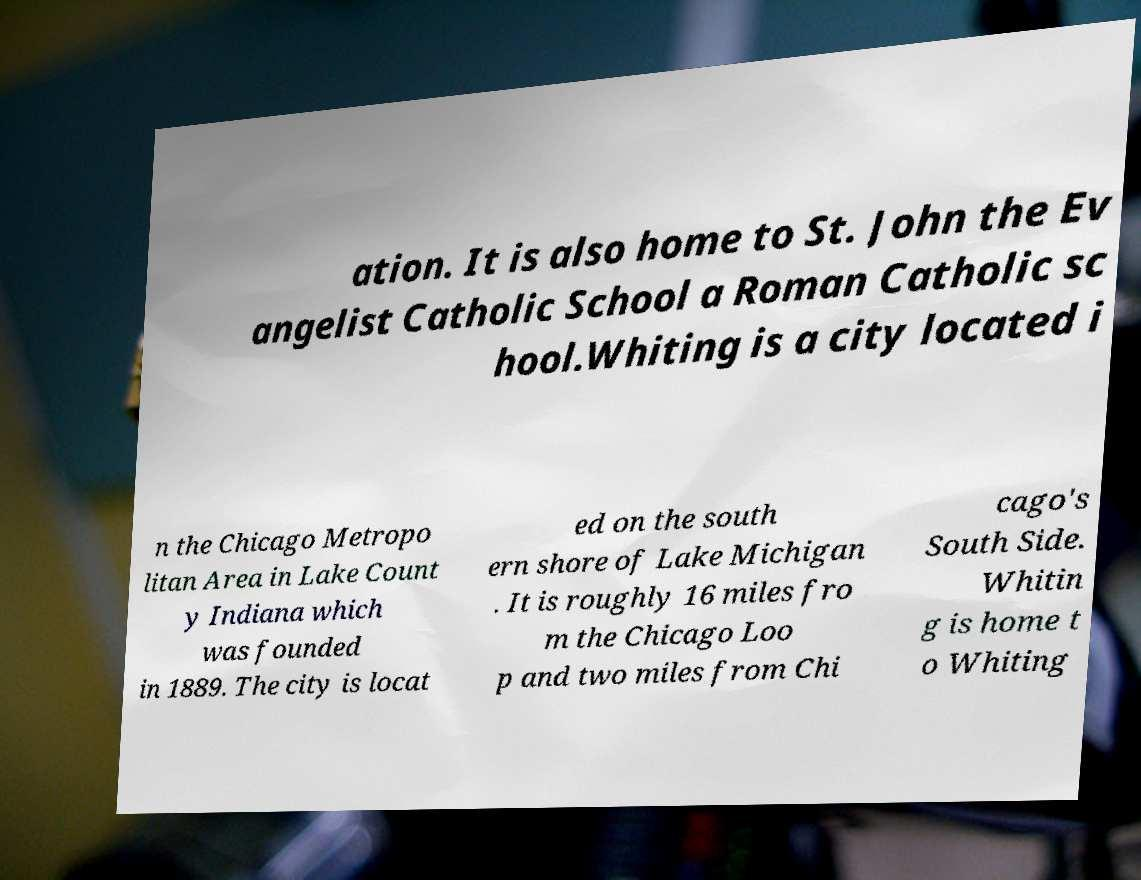There's text embedded in this image that I need extracted. Can you transcribe it verbatim? ation. It is also home to St. John the Ev angelist Catholic School a Roman Catholic sc hool.Whiting is a city located i n the Chicago Metropo litan Area in Lake Count y Indiana which was founded in 1889. The city is locat ed on the south ern shore of Lake Michigan . It is roughly 16 miles fro m the Chicago Loo p and two miles from Chi cago's South Side. Whitin g is home t o Whiting 